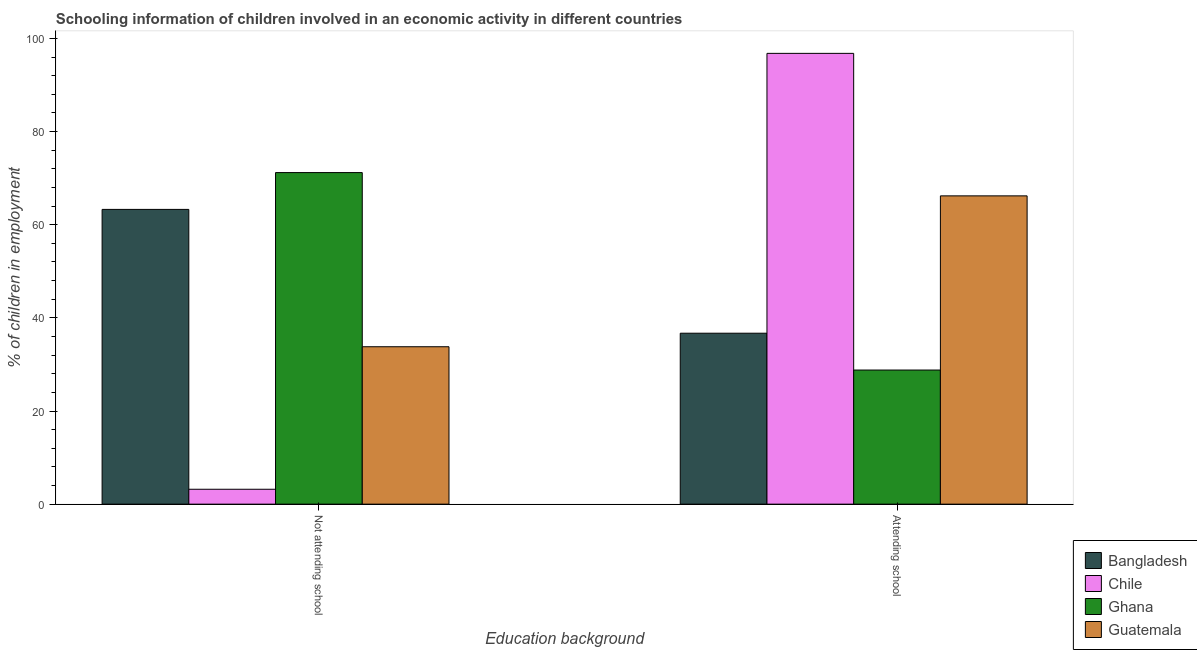How many different coloured bars are there?
Your answer should be compact. 4. How many groups of bars are there?
Your answer should be compact. 2. Are the number of bars per tick equal to the number of legend labels?
Offer a terse response. Yes. What is the label of the 1st group of bars from the left?
Your answer should be compact. Not attending school. What is the percentage of employed children who are not attending school in Guatemala?
Provide a succinct answer. 33.8. Across all countries, what is the maximum percentage of employed children who are not attending school?
Your answer should be compact. 71.2. Across all countries, what is the minimum percentage of employed children who are attending school?
Offer a terse response. 28.8. What is the total percentage of employed children who are attending school in the graph?
Make the answer very short. 228.51. What is the difference between the percentage of employed children who are not attending school in Guatemala and that in Ghana?
Make the answer very short. -37.4. What is the average percentage of employed children who are attending school per country?
Make the answer very short. 57.13. What is the difference between the percentage of employed children who are attending school and percentage of employed children who are not attending school in Bangladesh?
Your answer should be compact. -26.59. What is the ratio of the percentage of employed children who are attending school in Guatemala to that in Bangladesh?
Make the answer very short. 1.8. What does the 2nd bar from the left in Attending school represents?
Offer a terse response. Chile. What is the difference between two consecutive major ticks on the Y-axis?
Keep it short and to the point. 20. Are the values on the major ticks of Y-axis written in scientific E-notation?
Make the answer very short. No. Does the graph contain any zero values?
Make the answer very short. No. How are the legend labels stacked?
Offer a terse response. Vertical. What is the title of the graph?
Your answer should be very brief. Schooling information of children involved in an economic activity in different countries. Does "Bhutan" appear as one of the legend labels in the graph?
Give a very brief answer. No. What is the label or title of the X-axis?
Ensure brevity in your answer.  Education background. What is the label or title of the Y-axis?
Your response must be concise. % of children in employment. What is the % of children in employment in Bangladesh in Not attending school?
Your answer should be compact. 63.29. What is the % of children in employment in Ghana in Not attending school?
Your answer should be compact. 71.2. What is the % of children in employment of Guatemala in Not attending school?
Your answer should be very brief. 33.8. What is the % of children in employment of Bangladesh in Attending school?
Your answer should be compact. 36.71. What is the % of children in employment of Chile in Attending school?
Your response must be concise. 96.8. What is the % of children in employment in Ghana in Attending school?
Make the answer very short. 28.8. What is the % of children in employment in Guatemala in Attending school?
Ensure brevity in your answer.  66.2. Across all Education background, what is the maximum % of children in employment in Bangladesh?
Your answer should be compact. 63.29. Across all Education background, what is the maximum % of children in employment in Chile?
Make the answer very short. 96.8. Across all Education background, what is the maximum % of children in employment in Ghana?
Ensure brevity in your answer.  71.2. Across all Education background, what is the maximum % of children in employment of Guatemala?
Your answer should be compact. 66.2. Across all Education background, what is the minimum % of children in employment in Bangladesh?
Keep it short and to the point. 36.71. Across all Education background, what is the minimum % of children in employment of Chile?
Keep it short and to the point. 3.2. Across all Education background, what is the minimum % of children in employment of Ghana?
Give a very brief answer. 28.8. Across all Education background, what is the minimum % of children in employment in Guatemala?
Provide a short and direct response. 33.8. What is the total % of children in employment in Bangladesh in the graph?
Keep it short and to the point. 100. What is the total % of children in employment in Ghana in the graph?
Your response must be concise. 100. What is the difference between the % of children in employment of Bangladesh in Not attending school and that in Attending school?
Your response must be concise. 26.59. What is the difference between the % of children in employment of Chile in Not attending school and that in Attending school?
Provide a succinct answer. -93.6. What is the difference between the % of children in employment of Ghana in Not attending school and that in Attending school?
Offer a terse response. 42.4. What is the difference between the % of children in employment of Guatemala in Not attending school and that in Attending school?
Your answer should be compact. -32.4. What is the difference between the % of children in employment of Bangladesh in Not attending school and the % of children in employment of Chile in Attending school?
Your response must be concise. -33.51. What is the difference between the % of children in employment in Bangladesh in Not attending school and the % of children in employment in Ghana in Attending school?
Give a very brief answer. 34.49. What is the difference between the % of children in employment of Bangladesh in Not attending school and the % of children in employment of Guatemala in Attending school?
Offer a very short reply. -2.91. What is the difference between the % of children in employment of Chile in Not attending school and the % of children in employment of Ghana in Attending school?
Give a very brief answer. -25.6. What is the difference between the % of children in employment of Chile in Not attending school and the % of children in employment of Guatemala in Attending school?
Ensure brevity in your answer.  -63. What is the average % of children in employment in Bangladesh per Education background?
Your answer should be very brief. 50. What is the difference between the % of children in employment of Bangladesh and % of children in employment of Chile in Not attending school?
Your response must be concise. 60.09. What is the difference between the % of children in employment of Bangladesh and % of children in employment of Ghana in Not attending school?
Offer a terse response. -7.91. What is the difference between the % of children in employment of Bangladesh and % of children in employment of Guatemala in Not attending school?
Provide a succinct answer. 29.49. What is the difference between the % of children in employment of Chile and % of children in employment of Ghana in Not attending school?
Ensure brevity in your answer.  -68. What is the difference between the % of children in employment in Chile and % of children in employment in Guatemala in Not attending school?
Keep it short and to the point. -30.6. What is the difference between the % of children in employment of Ghana and % of children in employment of Guatemala in Not attending school?
Provide a succinct answer. 37.4. What is the difference between the % of children in employment of Bangladesh and % of children in employment of Chile in Attending school?
Your answer should be very brief. -60.09. What is the difference between the % of children in employment in Bangladesh and % of children in employment in Ghana in Attending school?
Offer a very short reply. 7.91. What is the difference between the % of children in employment of Bangladesh and % of children in employment of Guatemala in Attending school?
Your answer should be compact. -29.49. What is the difference between the % of children in employment in Chile and % of children in employment in Ghana in Attending school?
Make the answer very short. 68. What is the difference between the % of children in employment of Chile and % of children in employment of Guatemala in Attending school?
Make the answer very short. 30.6. What is the difference between the % of children in employment of Ghana and % of children in employment of Guatemala in Attending school?
Your answer should be compact. -37.4. What is the ratio of the % of children in employment of Bangladesh in Not attending school to that in Attending school?
Your response must be concise. 1.72. What is the ratio of the % of children in employment in Chile in Not attending school to that in Attending school?
Keep it short and to the point. 0.03. What is the ratio of the % of children in employment in Ghana in Not attending school to that in Attending school?
Provide a short and direct response. 2.47. What is the ratio of the % of children in employment of Guatemala in Not attending school to that in Attending school?
Your answer should be very brief. 0.51. What is the difference between the highest and the second highest % of children in employment in Bangladesh?
Make the answer very short. 26.59. What is the difference between the highest and the second highest % of children in employment of Chile?
Give a very brief answer. 93.6. What is the difference between the highest and the second highest % of children in employment of Ghana?
Offer a terse response. 42.4. What is the difference between the highest and the second highest % of children in employment in Guatemala?
Offer a very short reply. 32.4. What is the difference between the highest and the lowest % of children in employment of Bangladesh?
Your answer should be compact. 26.59. What is the difference between the highest and the lowest % of children in employment in Chile?
Keep it short and to the point. 93.6. What is the difference between the highest and the lowest % of children in employment of Ghana?
Provide a succinct answer. 42.4. What is the difference between the highest and the lowest % of children in employment in Guatemala?
Ensure brevity in your answer.  32.4. 